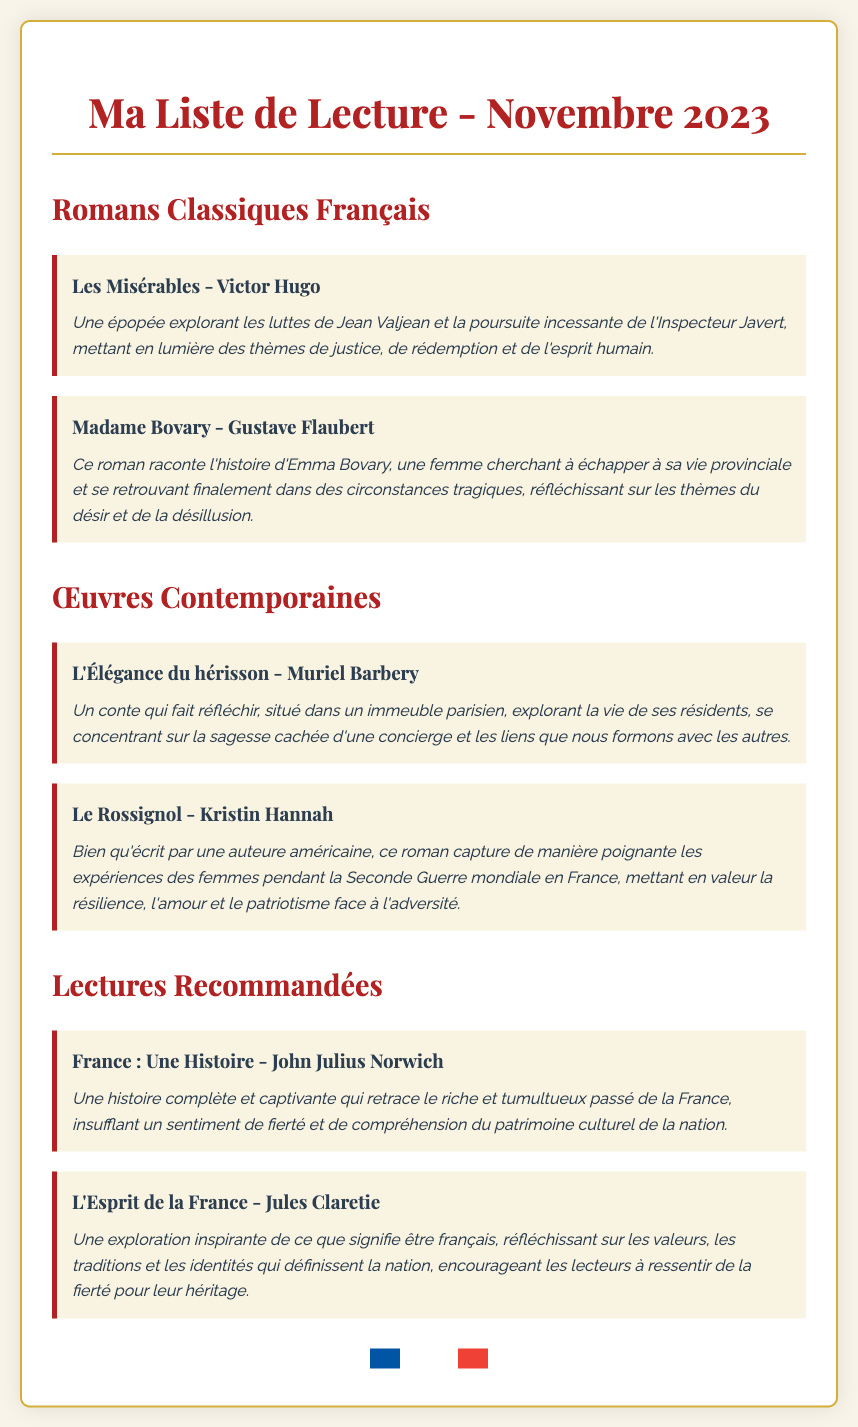What is the title of the first classic French novel listed? The first classic French novel listed in the document is "Les Misérables."
Answer: Les Misérables Who is the author of "Madame Bovary"? The author of "Madame Bovary," as mentioned in the document, is Gustave Flaubert.
Answer: Gustave Flaubert How many contemporary works are included in the reading list? The document lists two contemporary works under the "Œuvres Contemporaines" section.
Answer: 2 Which novel highlights women's experiences during World War II in France? The novel that highlights women's experiences during World War II in France is "Le Rossignol."
Answer: Le Rossignol What is the title of the recommended reading that chronicles France's history? The recommended reading that chronicles France's history is "France : Une Histoire."
Answer: France : Une Histoire What is the main theme of "L'Esprit de la France"? The main theme of "L'Esprit de la France" is an exploration of what it means to be French.
Answer: Être français How many books are listed under "Lectures Recommandées"? The document includes two books listed under "Lectures Recommandées."
Answer: 2 Who wrote "L'Élégance du hérisson"? The author of "L'Élégance du hérisson" is Muriel Barbery.
Answer: Muriel Barbery What sentiment does "France : Une Histoire" aim to instill in readers? "France : Une Histoire" aims to instill a sense of pride in understanding the nation's cultural heritage.
Answer: Fierté 